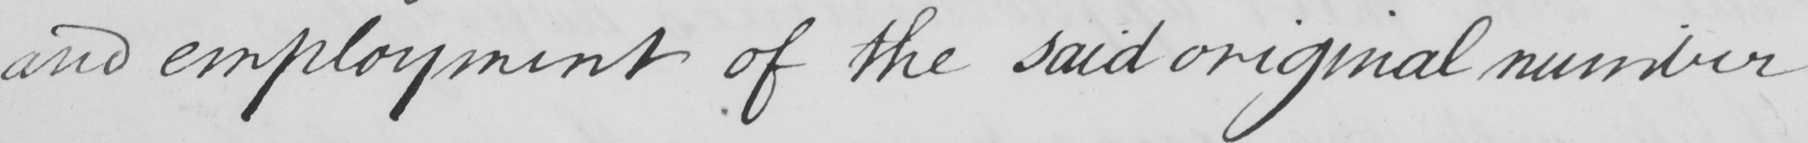Can you read and transcribe this handwriting? and employment of the said original number 